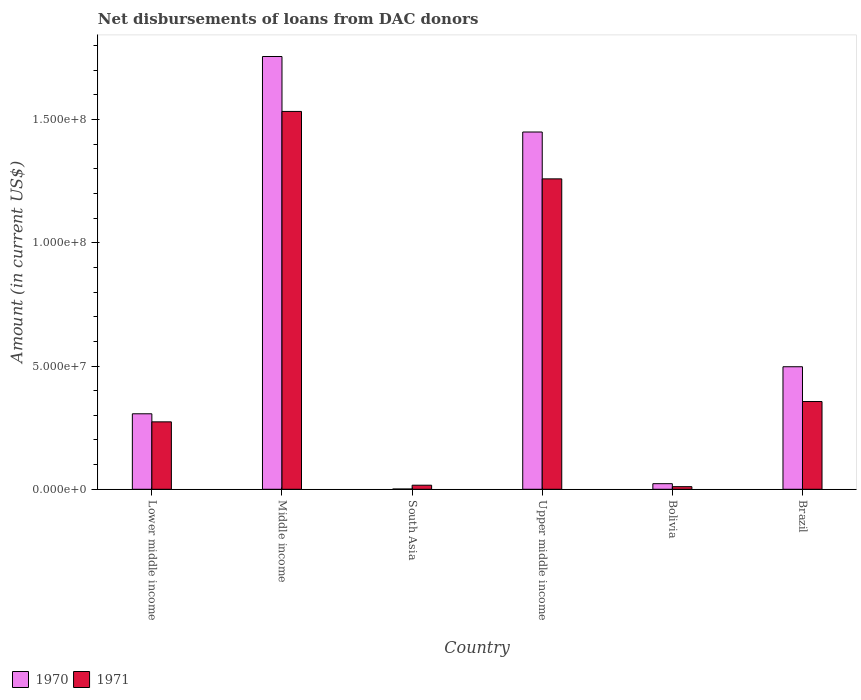How many different coloured bars are there?
Provide a succinct answer. 2. How many groups of bars are there?
Provide a short and direct response. 6. Are the number of bars on each tick of the X-axis equal?
Offer a very short reply. Yes. How many bars are there on the 1st tick from the left?
Offer a terse response. 2. How many bars are there on the 5th tick from the right?
Provide a short and direct response. 2. What is the label of the 5th group of bars from the left?
Provide a short and direct response. Bolivia. What is the amount of loans disbursed in 1971 in South Asia?
Offer a very short reply. 1.65e+06. Across all countries, what is the maximum amount of loans disbursed in 1971?
Make the answer very short. 1.53e+08. Across all countries, what is the minimum amount of loans disbursed in 1970?
Your response must be concise. 1.09e+05. In which country was the amount of loans disbursed in 1970 maximum?
Provide a short and direct response. Middle income. In which country was the amount of loans disbursed in 1971 minimum?
Provide a succinct answer. Bolivia. What is the total amount of loans disbursed in 1971 in the graph?
Your response must be concise. 3.45e+08. What is the difference between the amount of loans disbursed in 1971 in Bolivia and that in Upper middle income?
Ensure brevity in your answer.  -1.25e+08. What is the difference between the amount of loans disbursed in 1971 in Lower middle income and the amount of loans disbursed in 1970 in South Asia?
Your response must be concise. 2.72e+07. What is the average amount of loans disbursed in 1971 per country?
Your answer should be very brief. 5.75e+07. What is the difference between the amount of loans disbursed of/in 1970 and amount of loans disbursed of/in 1971 in South Asia?
Give a very brief answer. -1.54e+06. What is the ratio of the amount of loans disbursed in 1971 in South Asia to that in Upper middle income?
Your answer should be compact. 0.01. Is the difference between the amount of loans disbursed in 1970 in Brazil and Lower middle income greater than the difference between the amount of loans disbursed in 1971 in Brazil and Lower middle income?
Ensure brevity in your answer.  Yes. What is the difference between the highest and the second highest amount of loans disbursed in 1970?
Ensure brevity in your answer.  3.06e+07. What is the difference between the highest and the lowest amount of loans disbursed in 1970?
Ensure brevity in your answer.  1.75e+08. In how many countries, is the amount of loans disbursed in 1970 greater than the average amount of loans disbursed in 1970 taken over all countries?
Your answer should be compact. 2. Is the sum of the amount of loans disbursed in 1970 in Bolivia and South Asia greater than the maximum amount of loans disbursed in 1971 across all countries?
Your answer should be compact. No. What does the 2nd bar from the left in Bolivia represents?
Provide a short and direct response. 1971. Are all the bars in the graph horizontal?
Provide a short and direct response. No. How many countries are there in the graph?
Provide a short and direct response. 6. Are the values on the major ticks of Y-axis written in scientific E-notation?
Your response must be concise. Yes. Does the graph contain grids?
Your answer should be compact. No. How are the legend labels stacked?
Ensure brevity in your answer.  Horizontal. What is the title of the graph?
Ensure brevity in your answer.  Net disbursements of loans from DAC donors. Does "1999" appear as one of the legend labels in the graph?
Your answer should be very brief. No. What is the label or title of the X-axis?
Provide a succinct answer. Country. What is the label or title of the Y-axis?
Keep it short and to the point. Amount (in current US$). What is the Amount (in current US$) of 1970 in Lower middle income?
Your answer should be compact. 3.06e+07. What is the Amount (in current US$) of 1971 in Lower middle income?
Ensure brevity in your answer.  2.74e+07. What is the Amount (in current US$) of 1970 in Middle income?
Provide a succinct answer. 1.76e+08. What is the Amount (in current US$) of 1971 in Middle income?
Provide a succinct answer. 1.53e+08. What is the Amount (in current US$) in 1970 in South Asia?
Provide a succinct answer. 1.09e+05. What is the Amount (in current US$) of 1971 in South Asia?
Provide a succinct answer. 1.65e+06. What is the Amount (in current US$) of 1970 in Upper middle income?
Ensure brevity in your answer.  1.45e+08. What is the Amount (in current US$) in 1971 in Upper middle income?
Offer a terse response. 1.26e+08. What is the Amount (in current US$) of 1970 in Bolivia?
Offer a very short reply. 2.27e+06. What is the Amount (in current US$) in 1971 in Bolivia?
Your response must be concise. 1.06e+06. What is the Amount (in current US$) in 1970 in Brazil?
Make the answer very short. 4.97e+07. What is the Amount (in current US$) in 1971 in Brazil?
Ensure brevity in your answer.  3.56e+07. Across all countries, what is the maximum Amount (in current US$) in 1970?
Offer a very short reply. 1.76e+08. Across all countries, what is the maximum Amount (in current US$) in 1971?
Your response must be concise. 1.53e+08. Across all countries, what is the minimum Amount (in current US$) in 1970?
Give a very brief answer. 1.09e+05. Across all countries, what is the minimum Amount (in current US$) in 1971?
Make the answer very short. 1.06e+06. What is the total Amount (in current US$) in 1970 in the graph?
Ensure brevity in your answer.  4.03e+08. What is the total Amount (in current US$) in 1971 in the graph?
Give a very brief answer. 3.45e+08. What is the difference between the Amount (in current US$) of 1970 in Lower middle income and that in Middle income?
Provide a succinct answer. -1.45e+08. What is the difference between the Amount (in current US$) of 1971 in Lower middle income and that in Middle income?
Give a very brief answer. -1.26e+08. What is the difference between the Amount (in current US$) in 1970 in Lower middle income and that in South Asia?
Your response must be concise. 3.05e+07. What is the difference between the Amount (in current US$) in 1971 in Lower middle income and that in South Asia?
Ensure brevity in your answer.  2.57e+07. What is the difference between the Amount (in current US$) in 1970 in Lower middle income and that in Upper middle income?
Keep it short and to the point. -1.14e+08. What is the difference between the Amount (in current US$) in 1971 in Lower middle income and that in Upper middle income?
Offer a terse response. -9.86e+07. What is the difference between the Amount (in current US$) in 1970 in Lower middle income and that in Bolivia?
Make the answer very short. 2.84e+07. What is the difference between the Amount (in current US$) of 1971 in Lower middle income and that in Bolivia?
Provide a short and direct response. 2.63e+07. What is the difference between the Amount (in current US$) in 1970 in Lower middle income and that in Brazil?
Ensure brevity in your answer.  -1.91e+07. What is the difference between the Amount (in current US$) of 1971 in Lower middle income and that in Brazil?
Offer a very short reply. -8.24e+06. What is the difference between the Amount (in current US$) of 1970 in Middle income and that in South Asia?
Offer a very short reply. 1.75e+08. What is the difference between the Amount (in current US$) of 1971 in Middle income and that in South Asia?
Provide a short and direct response. 1.52e+08. What is the difference between the Amount (in current US$) in 1970 in Middle income and that in Upper middle income?
Provide a succinct answer. 3.06e+07. What is the difference between the Amount (in current US$) in 1971 in Middle income and that in Upper middle income?
Make the answer very short. 2.74e+07. What is the difference between the Amount (in current US$) of 1970 in Middle income and that in Bolivia?
Give a very brief answer. 1.73e+08. What is the difference between the Amount (in current US$) of 1971 in Middle income and that in Bolivia?
Your response must be concise. 1.52e+08. What is the difference between the Amount (in current US$) in 1970 in Middle income and that in Brazil?
Make the answer very short. 1.26e+08. What is the difference between the Amount (in current US$) in 1971 in Middle income and that in Brazil?
Provide a short and direct response. 1.18e+08. What is the difference between the Amount (in current US$) in 1970 in South Asia and that in Upper middle income?
Make the answer very short. -1.45e+08. What is the difference between the Amount (in current US$) in 1971 in South Asia and that in Upper middle income?
Your response must be concise. -1.24e+08. What is the difference between the Amount (in current US$) of 1970 in South Asia and that in Bolivia?
Ensure brevity in your answer.  -2.16e+06. What is the difference between the Amount (in current US$) of 1971 in South Asia and that in Bolivia?
Your answer should be very brief. 5.92e+05. What is the difference between the Amount (in current US$) in 1970 in South Asia and that in Brazil?
Your response must be concise. -4.96e+07. What is the difference between the Amount (in current US$) of 1971 in South Asia and that in Brazil?
Provide a short and direct response. -3.39e+07. What is the difference between the Amount (in current US$) of 1970 in Upper middle income and that in Bolivia?
Provide a succinct answer. 1.43e+08. What is the difference between the Amount (in current US$) in 1971 in Upper middle income and that in Bolivia?
Your response must be concise. 1.25e+08. What is the difference between the Amount (in current US$) in 1970 in Upper middle income and that in Brazil?
Keep it short and to the point. 9.52e+07. What is the difference between the Amount (in current US$) of 1971 in Upper middle income and that in Brazil?
Make the answer very short. 9.03e+07. What is the difference between the Amount (in current US$) in 1970 in Bolivia and that in Brazil?
Your answer should be very brief. -4.74e+07. What is the difference between the Amount (in current US$) of 1971 in Bolivia and that in Brazil?
Keep it short and to the point. -3.45e+07. What is the difference between the Amount (in current US$) of 1970 in Lower middle income and the Amount (in current US$) of 1971 in Middle income?
Keep it short and to the point. -1.23e+08. What is the difference between the Amount (in current US$) of 1970 in Lower middle income and the Amount (in current US$) of 1971 in South Asia?
Provide a succinct answer. 2.90e+07. What is the difference between the Amount (in current US$) of 1970 in Lower middle income and the Amount (in current US$) of 1971 in Upper middle income?
Provide a short and direct response. -9.53e+07. What is the difference between the Amount (in current US$) in 1970 in Lower middle income and the Amount (in current US$) in 1971 in Bolivia?
Make the answer very short. 2.96e+07. What is the difference between the Amount (in current US$) in 1970 in Lower middle income and the Amount (in current US$) in 1971 in Brazil?
Ensure brevity in your answer.  -4.97e+06. What is the difference between the Amount (in current US$) in 1970 in Middle income and the Amount (in current US$) in 1971 in South Asia?
Provide a succinct answer. 1.74e+08. What is the difference between the Amount (in current US$) of 1970 in Middle income and the Amount (in current US$) of 1971 in Upper middle income?
Provide a short and direct response. 4.96e+07. What is the difference between the Amount (in current US$) in 1970 in Middle income and the Amount (in current US$) in 1971 in Bolivia?
Offer a terse response. 1.74e+08. What is the difference between the Amount (in current US$) of 1970 in Middle income and the Amount (in current US$) of 1971 in Brazil?
Provide a succinct answer. 1.40e+08. What is the difference between the Amount (in current US$) in 1970 in South Asia and the Amount (in current US$) in 1971 in Upper middle income?
Keep it short and to the point. -1.26e+08. What is the difference between the Amount (in current US$) of 1970 in South Asia and the Amount (in current US$) of 1971 in Bolivia?
Give a very brief answer. -9.49e+05. What is the difference between the Amount (in current US$) in 1970 in South Asia and the Amount (in current US$) in 1971 in Brazil?
Your answer should be compact. -3.55e+07. What is the difference between the Amount (in current US$) of 1970 in Upper middle income and the Amount (in current US$) of 1971 in Bolivia?
Your response must be concise. 1.44e+08. What is the difference between the Amount (in current US$) in 1970 in Upper middle income and the Amount (in current US$) in 1971 in Brazil?
Keep it short and to the point. 1.09e+08. What is the difference between the Amount (in current US$) in 1970 in Bolivia and the Amount (in current US$) in 1971 in Brazil?
Give a very brief answer. -3.33e+07. What is the average Amount (in current US$) of 1970 per country?
Your response must be concise. 6.72e+07. What is the average Amount (in current US$) of 1971 per country?
Provide a succinct answer. 5.75e+07. What is the difference between the Amount (in current US$) in 1970 and Amount (in current US$) in 1971 in Lower middle income?
Give a very brief answer. 3.27e+06. What is the difference between the Amount (in current US$) of 1970 and Amount (in current US$) of 1971 in Middle income?
Offer a terse response. 2.23e+07. What is the difference between the Amount (in current US$) in 1970 and Amount (in current US$) in 1971 in South Asia?
Offer a terse response. -1.54e+06. What is the difference between the Amount (in current US$) in 1970 and Amount (in current US$) in 1971 in Upper middle income?
Your answer should be compact. 1.90e+07. What is the difference between the Amount (in current US$) of 1970 and Amount (in current US$) of 1971 in Bolivia?
Provide a short and direct response. 1.21e+06. What is the difference between the Amount (in current US$) of 1970 and Amount (in current US$) of 1971 in Brazil?
Give a very brief answer. 1.41e+07. What is the ratio of the Amount (in current US$) of 1970 in Lower middle income to that in Middle income?
Keep it short and to the point. 0.17. What is the ratio of the Amount (in current US$) in 1971 in Lower middle income to that in Middle income?
Provide a succinct answer. 0.18. What is the ratio of the Amount (in current US$) in 1970 in Lower middle income to that in South Asia?
Your answer should be compact. 280.94. What is the ratio of the Amount (in current US$) in 1971 in Lower middle income to that in South Asia?
Offer a terse response. 16.58. What is the ratio of the Amount (in current US$) of 1970 in Lower middle income to that in Upper middle income?
Offer a terse response. 0.21. What is the ratio of the Amount (in current US$) in 1971 in Lower middle income to that in Upper middle income?
Your response must be concise. 0.22. What is the ratio of the Amount (in current US$) in 1970 in Lower middle income to that in Bolivia?
Your answer should be very brief. 13.49. What is the ratio of the Amount (in current US$) of 1971 in Lower middle income to that in Bolivia?
Your response must be concise. 25.85. What is the ratio of the Amount (in current US$) in 1970 in Lower middle income to that in Brazil?
Your answer should be very brief. 0.62. What is the ratio of the Amount (in current US$) in 1971 in Lower middle income to that in Brazil?
Offer a terse response. 0.77. What is the ratio of the Amount (in current US$) of 1970 in Middle income to that in South Asia?
Make the answer very short. 1610.58. What is the ratio of the Amount (in current US$) in 1971 in Middle income to that in South Asia?
Ensure brevity in your answer.  92.89. What is the ratio of the Amount (in current US$) of 1970 in Middle income to that in Upper middle income?
Make the answer very short. 1.21. What is the ratio of the Amount (in current US$) in 1971 in Middle income to that in Upper middle income?
Offer a very short reply. 1.22. What is the ratio of the Amount (in current US$) in 1970 in Middle income to that in Bolivia?
Offer a terse response. 77.34. What is the ratio of the Amount (in current US$) of 1971 in Middle income to that in Bolivia?
Provide a short and direct response. 144.87. What is the ratio of the Amount (in current US$) of 1970 in Middle income to that in Brazil?
Your response must be concise. 3.53. What is the ratio of the Amount (in current US$) of 1971 in Middle income to that in Brazil?
Give a very brief answer. 4.31. What is the ratio of the Amount (in current US$) of 1970 in South Asia to that in Upper middle income?
Ensure brevity in your answer.  0. What is the ratio of the Amount (in current US$) of 1971 in South Asia to that in Upper middle income?
Give a very brief answer. 0.01. What is the ratio of the Amount (in current US$) of 1970 in South Asia to that in Bolivia?
Provide a succinct answer. 0.05. What is the ratio of the Amount (in current US$) in 1971 in South Asia to that in Bolivia?
Provide a short and direct response. 1.56. What is the ratio of the Amount (in current US$) of 1970 in South Asia to that in Brazil?
Make the answer very short. 0. What is the ratio of the Amount (in current US$) in 1971 in South Asia to that in Brazil?
Provide a succinct answer. 0.05. What is the ratio of the Amount (in current US$) in 1970 in Upper middle income to that in Bolivia?
Your answer should be very brief. 63.85. What is the ratio of the Amount (in current US$) of 1971 in Upper middle income to that in Bolivia?
Offer a terse response. 119.02. What is the ratio of the Amount (in current US$) in 1970 in Upper middle income to that in Brazil?
Provide a short and direct response. 2.92. What is the ratio of the Amount (in current US$) of 1971 in Upper middle income to that in Brazil?
Make the answer very short. 3.54. What is the ratio of the Amount (in current US$) of 1970 in Bolivia to that in Brazil?
Keep it short and to the point. 0.05. What is the ratio of the Amount (in current US$) in 1971 in Bolivia to that in Brazil?
Provide a short and direct response. 0.03. What is the difference between the highest and the second highest Amount (in current US$) in 1970?
Your answer should be very brief. 3.06e+07. What is the difference between the highest and the second highest Amount (in current US$) in 1971?
Your response must be concise. 2.74e+07. What is the difference between the highest and the lowest Amount (in current US$) of 1970?
Your answer should be compact. 1.75e+08. What is the difference between the highest and the lowest Amount (in current US$) in 1971?
Provide a succinct answer. 1.52e+08. 